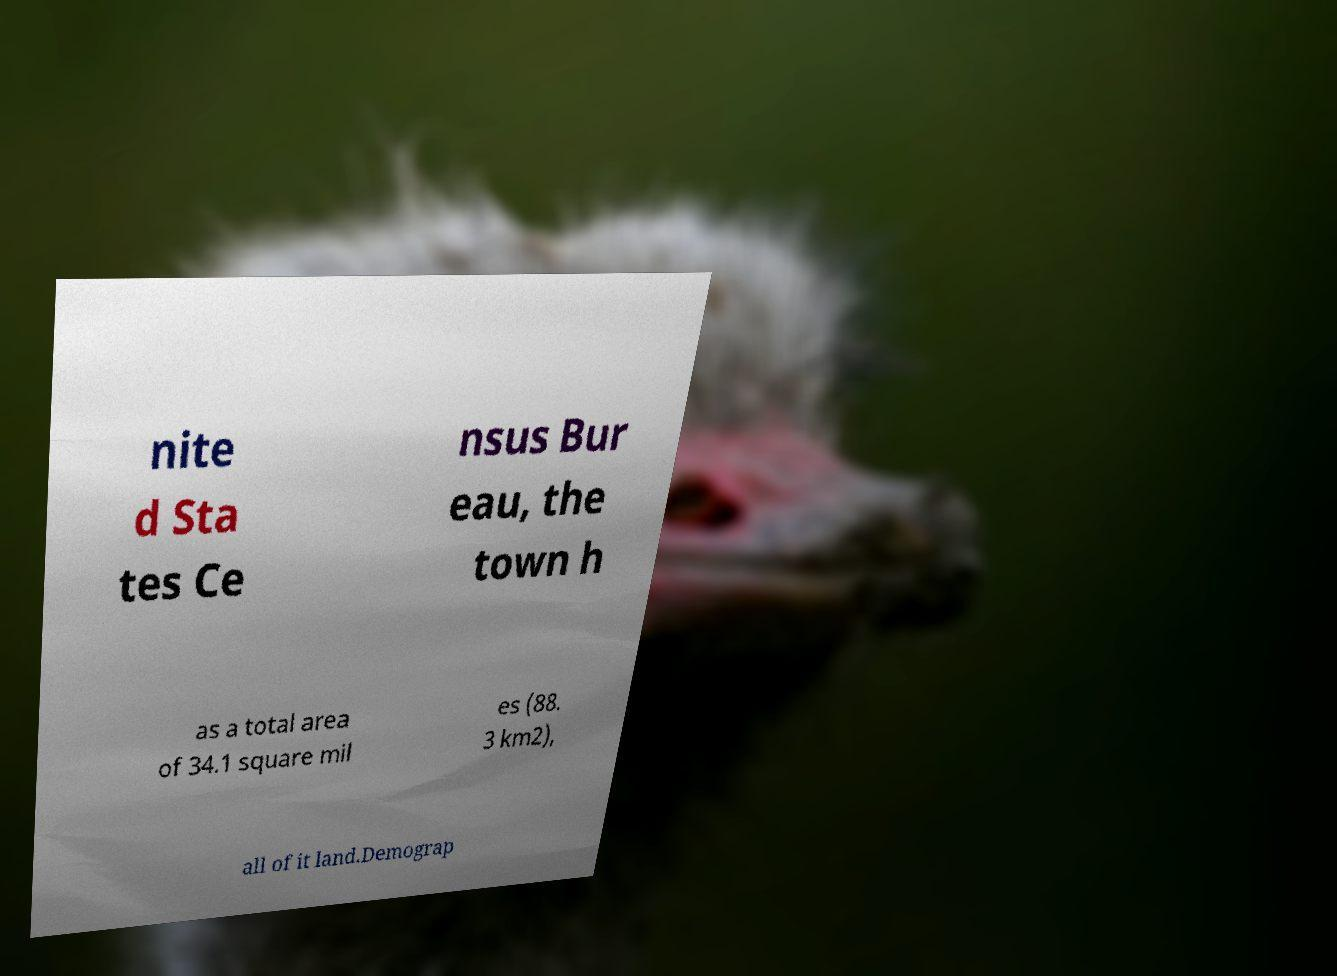Could you assist in decoding the text presented in this image and type it out clearly? nite d Sta tes Ce nsus Bur eau, the town h as a total area of 34.1 square mil es (88. 3 km2), all of it land.Demograp 